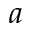Convert formula to latex. <formula><loc_0><loc_0><loc_500><loc_500>a</formula> 